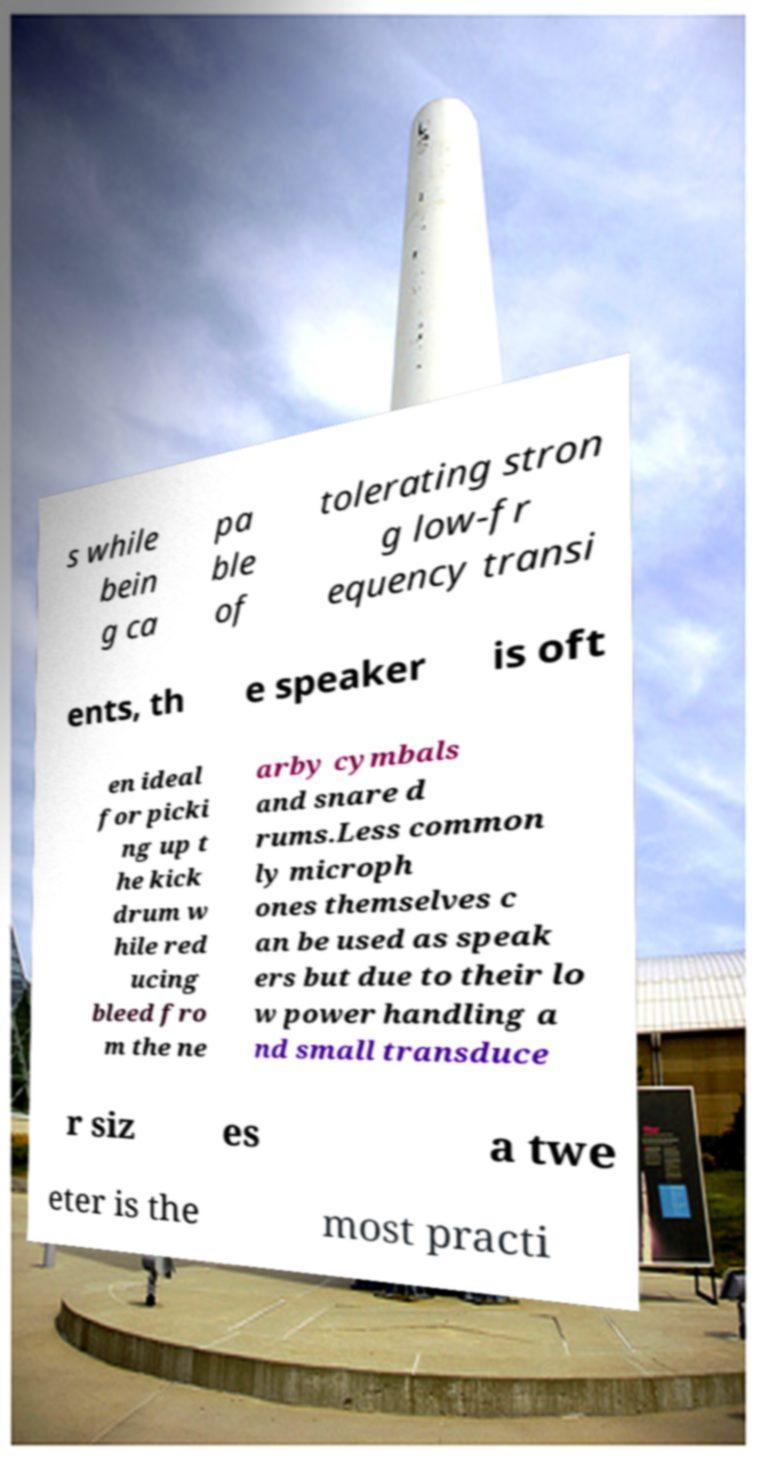Please identify and transcribe the text found in this image. s while bein g ca pa ble of tolerating stron g low-fr equency transi ents, th e speaker is oft en ideal for picki ng up t he kick drum w hile red ucing bleed fro m the ne arby cymbals and snare d rums.Less common ly microph ones themselves c an be used as speak ers but due to their lo w power handling a nd small transduce r siz es a twe eter is the most practi 